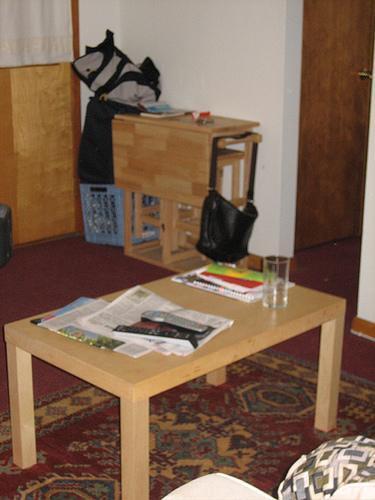How many books can be seen?
Give a very brief answer. 2. 